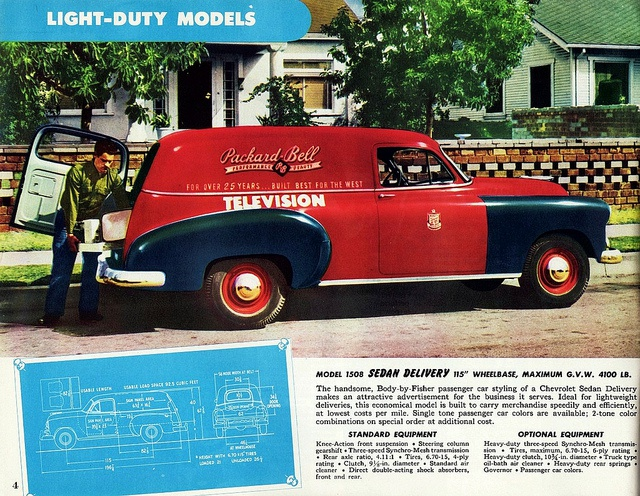Describe the objects in this image and their specific colors. I can see car in lightblue, black, brown, and ivory tones and people in lightblue, black, darkgreen, olive, and maroon tones in this image. 